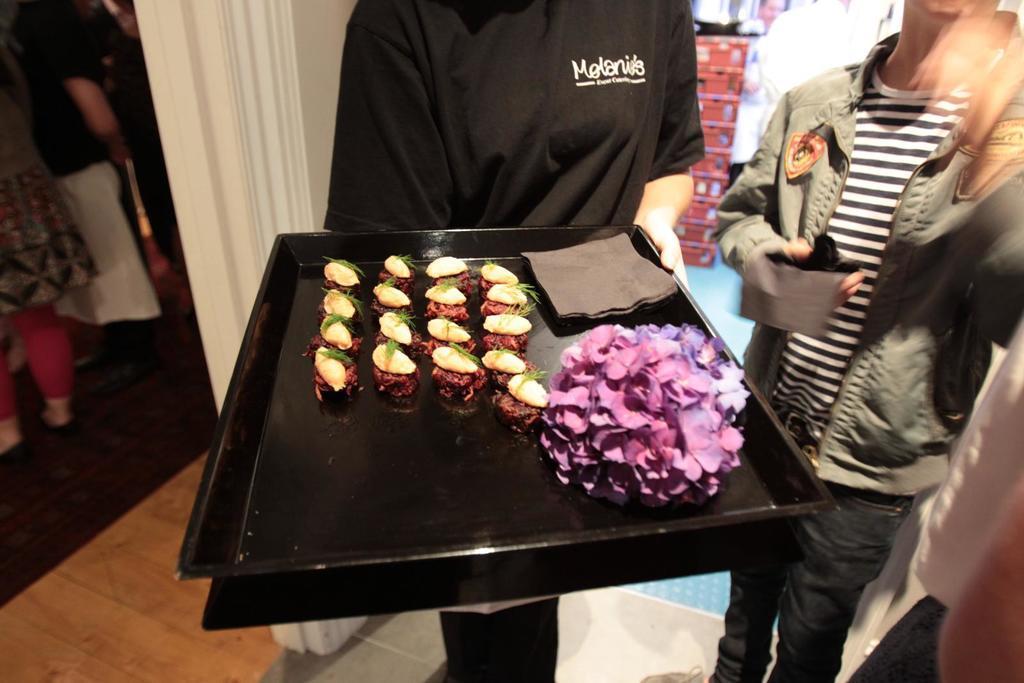How would you summarize this image in a sentence or two? This picture seems to be clicked inside the hall. In the center we can see a person wearing black color dress, holding a black color tray containing food items and some other items. On the right we can see another person wearing jacket, holding some object and standing. In the background we can see the group of persons, wall and many other objects. 